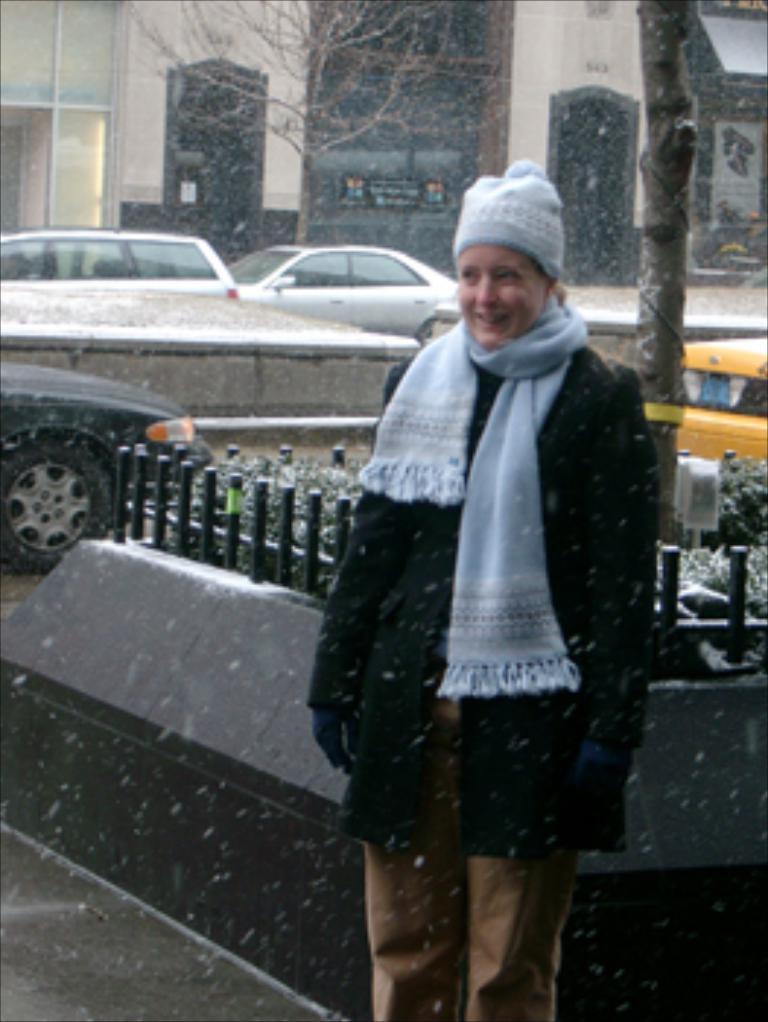Describe this image in one or two sentences. In this image in the foreground there is one woman who is standing and smiling, and in the background there are some houses trees and some vehicles and in the center there is a fence and some plants. At the bottom there is a walkway. 